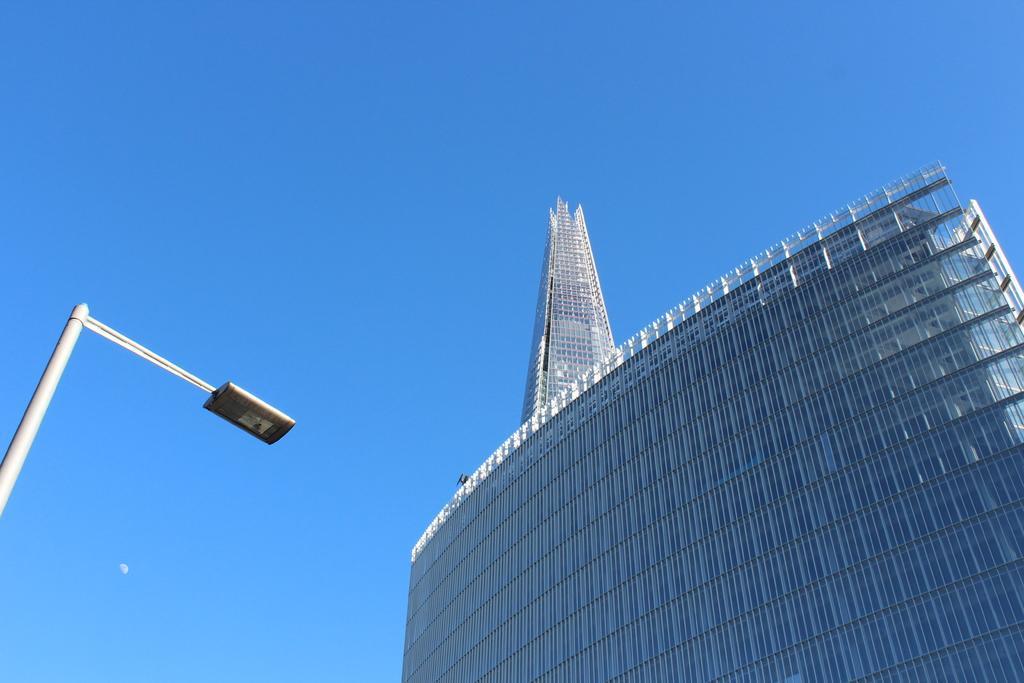Could you give a brief overview of what you see in this image? In the image we can see a building, made up of glass. We can even see a light pole, blue sky and a half moon. 